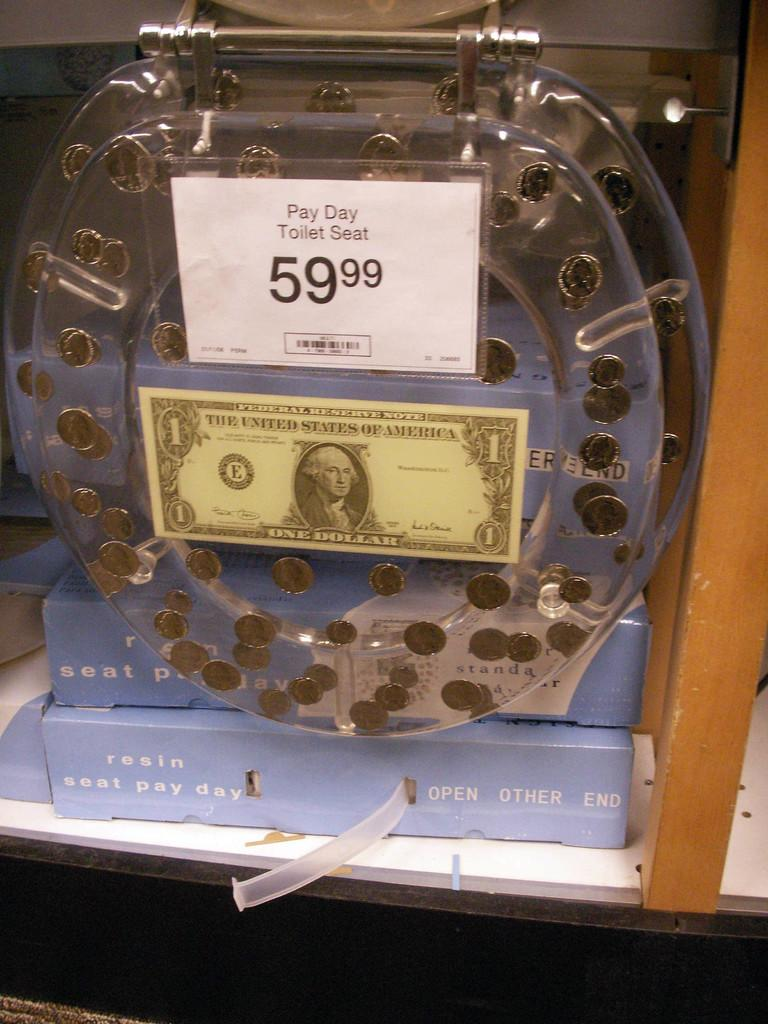<image>
Write a terse but informative summary of the picture. A toilet seat named Pay Day Toilet Seat on sale for 59.99. 